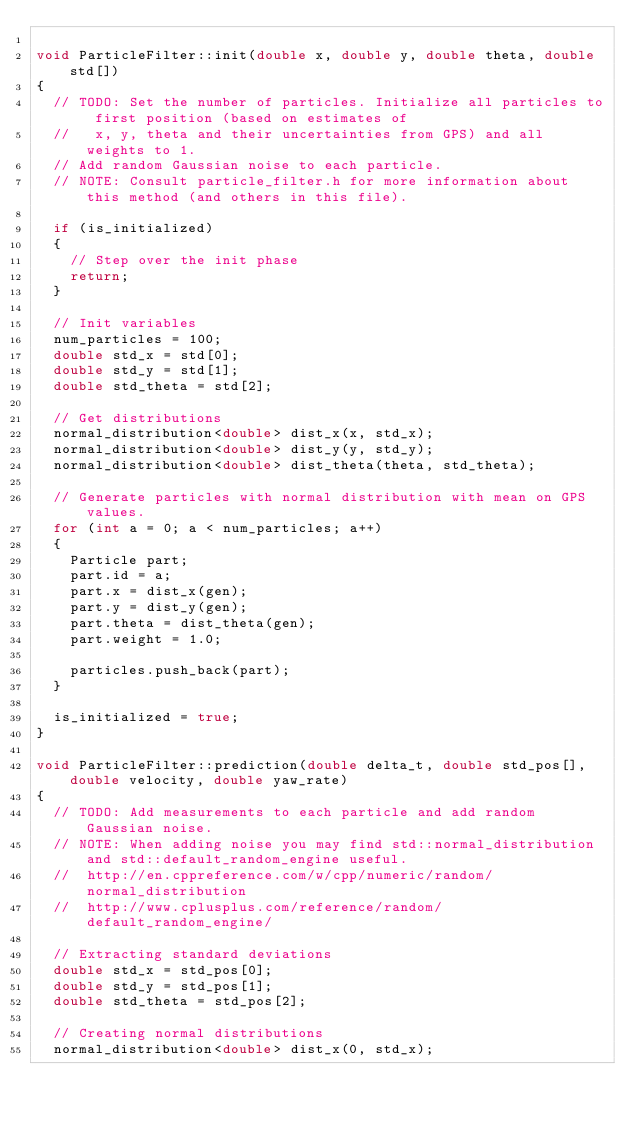Convert code to text. <code><loc_0><loc_0><loc_500><loc_500><_C++_>
void ParticleFilter::init(double x, double y, double theta, double std[])
{
  // TODO: Set the number of particles. Initialize all particles to first position (based on estimates of
  //   x, y, theta and their uncertainties from GPS) and all weights to 1.
  // Add random Gaussian noise to each particle.
  // NOTE: Consult particle_filter.h for more information about this method (and others in this file).

  if (is_initialized)
  {
    // Step over the init phase
    return;
  }

  // Init variables
  num_particles = 100;
  double std_x = std[0];
  double std_y = std[1];
  double std_theta = std[2];

  // Get distributions
  normal_distribution<double> dist_x(x, std_x);
  normal_distribution<double> dist_y(y, std_y);
  normal_distribution<double> dist_theta(theta, std_theta);

  // Generate particles with normal distribution with mean on GPS values.
  for (int a = 0; a < num_particles; a++)
  {
    Particle part;
    part.id = a;
    part.x = dist_x(gen);
    part.y = dist_y(gen);
    part.theta = dist_theta(gen);
    part.weight = 1.0;
  
    particles.push_back(part);
  }

  is_initialized = true;
}

void ParticleFilter::prediction(double delta_t, double std_pos[], double velocity, double yaw_rate)
{
  // TODO: Add measurements to each particle and add random Gaussian noise.
  // NOTE: When adding noise you may find std::normal_distribution and std::default_random_engine useful.
  //  http://en.cppreference.com/w/cpp/numeric/random/normal_distribution
  //  http://www.cplusplus.com/reference/random/default_random_engine/

  // Extracting standard deviations
  double std_x = std_pos[0];
  double std_y = std_pos[1];
  double std_theta = std_pos[2];

  // Creating normal distributions
  normal_distribution<double> dist_x(0, std_x);</code> 